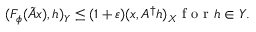Convert formula to latex. <formula><loc_0><loc_0><loc_500><loc_500>( F _ { \phi } ( \tilde { A } x ) , h ) _ { Y } \leq ( 1 + \varepsilon ) ( x , A ^ { \dagger } h ) _ { X } f o r h \in Y .</formula> 